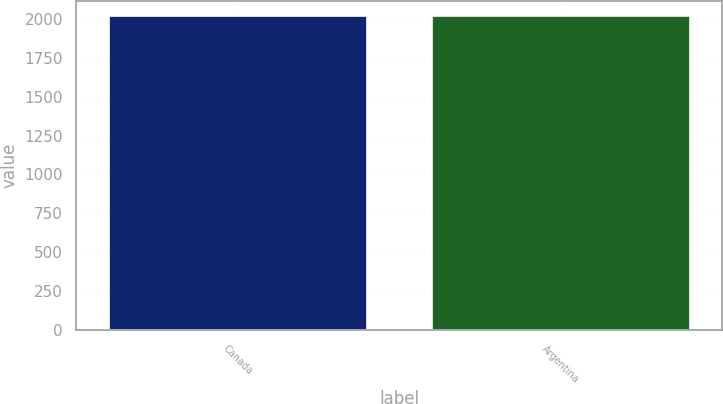Convert chart to OTSL. <chart><loc_0><loc_0><loc_500><loc_500><bar_chart><fcel>Canada<fcel>Argentina<nl><fcel>2014<fcel>2014.1<nl></chart> 